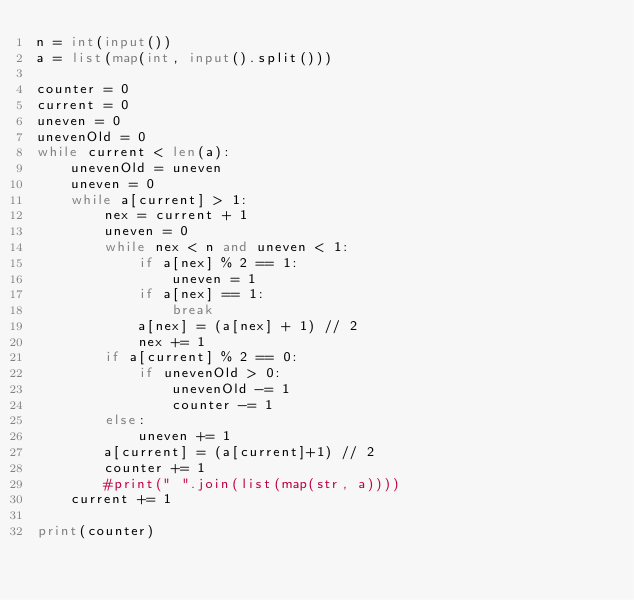<code> <loc_0><loc_0><loc_500><loc_500><_Python_>n = int(input())
a = list(map(int, input().split()))

counter = 0
current = 0
uneven = 0
unevenOld = 0
while current < len(a):
	unevenOld = uneven
	uneven = 0
	while a[current] > 1:
		nex = current + 1
		uneven = 0
		while nex < n and uneven < 1:
			if a[nex] % 2 == 1:
				uneven = 1
			if a[nex] == 1:
				break
			a[nex] = (a[nex] + 1) // 2
			nex += 1
		if a[current] % 2 == 0:
			if unevenOld > 0:
				unevenOld -= 1
				counter -= 1
		else:
			uneven += 1
		a[current] = (a[current]+1) // 2
		counter += 1
		#print(" ".join(list(map(str, a))))
	current += 1

print(counter)</code> 